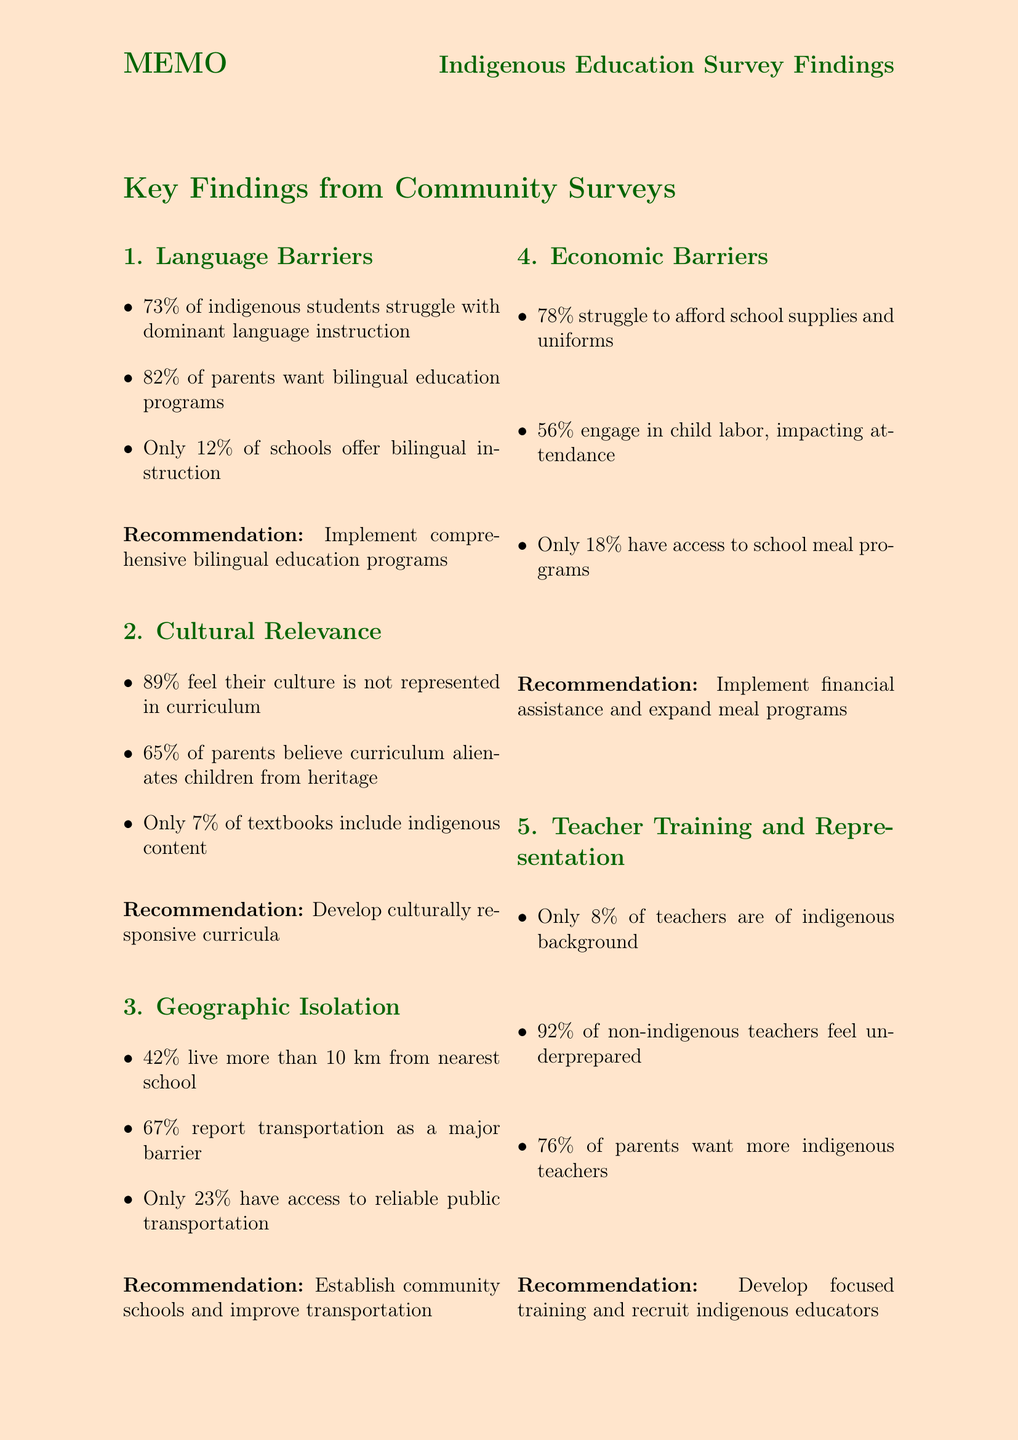What percentage of indigenous students reported difficulties with classroom instruction? The document states that 73% of indigenous students reported difficulty understanding classroom instruction.
Answer: 73% How many schools in indigenous areas offer bilingual instruction? The document mentions that only 12% of schools in indigenous areas offer bilingual instruction.
Answer: 12% What percentage of indigenous families struggled to afford school supplies and uniforms? The document states that 78% of indigenous families reported difficulty affording school supplies and uniforms.
Answer: 78% What is the sample size of the survey conducted? According to the document, the sample size for the survey was 5,000.
Answer: 5000 Which recommendation addresses cultural representation in education? The document recommends developing culturally responsive curricula that incorporate indigenous knowledge and perspectives.
Answer: Develop culturally responsive curricula What barrier do 67% of families report affecting school attendance? The document states that 67% of families reported transportation as a major barrier to regular school attendance.
Answer: Transportation What percentage of indigenous parents want more indigenous teachers? The document mentions that 76% of indigenous parents expressed a desire for more indigenous teachers in schools.
Answer: 76% Who is responsible for overseeing policy recommendations based on the survey? The document states that Sarah Thompson, Senior Policy Advisor, Ministry of Education, will oversee policy recommendations.
Answer: Sarah Thompson What is the geographic coverage of the survey? The document specifies that the survey covered 25 indigenous communities across 5 regions.
Answer: 25 indigenous communities across 5 regions 